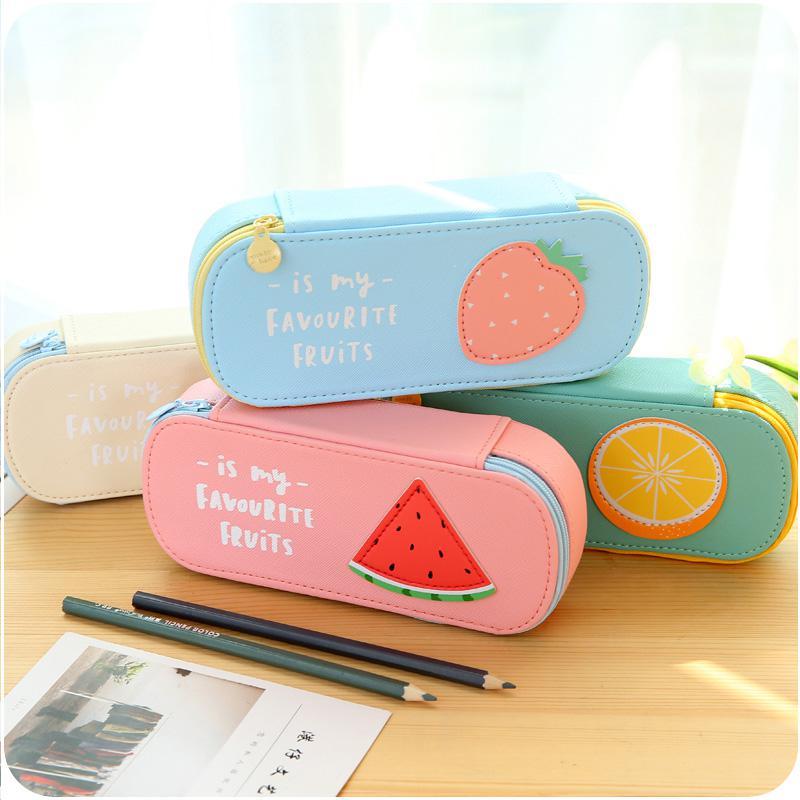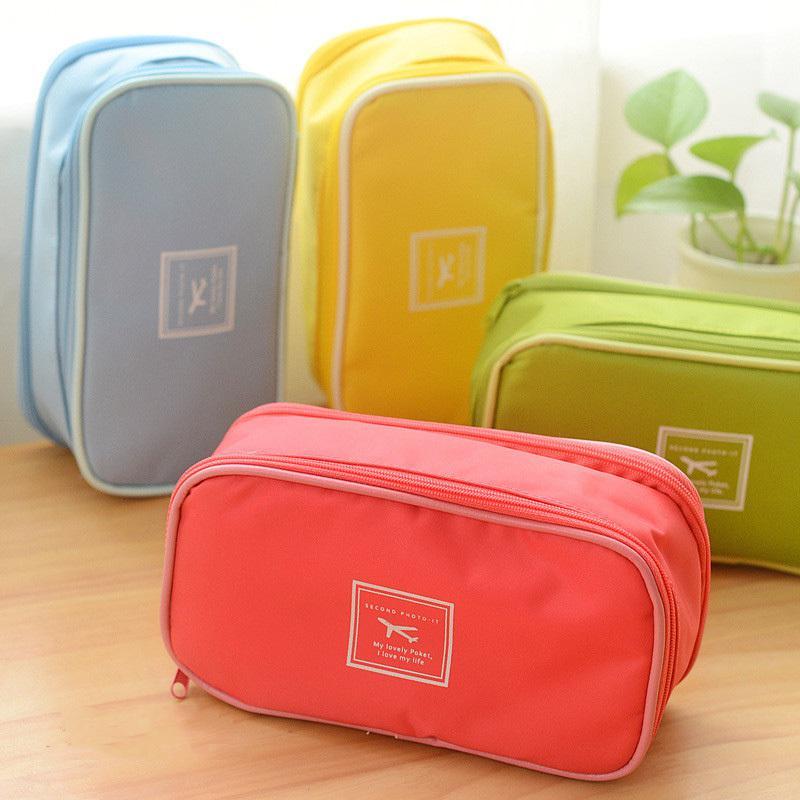The first image is the image on the left, the second image is the image on the right. Assess this claim about the two images: "At least one image shows exactly four pencil cases of different solid colors.". Correct or not? Answer yes or no. Yes. The first image is the image on the left, the second image is the image on the right. Analyze the images presented: Is the assertion "The right image contains four different colored small bags." valid? Answer yes or no. Yes. The first image is the image on the left, the second image is the image on the right. Examine the images to the left and right. Is the description "There are four cases in the image on the left." accurate? Answer yes or no. Yes. The first image is the image on the left, the second image is the image on the right. Examine the images to the left and right. Is the description "The image on the right contains no more than four handbags that are each a different color." accurate? Answer yes or no. Yes. The first image is the image on the left, the second image is the image on the right. For the images shown, is this caption "There is one yellow pencil case with an additional 3 to 4 different colors cases visible." true? Answer yes or no. Yes. 